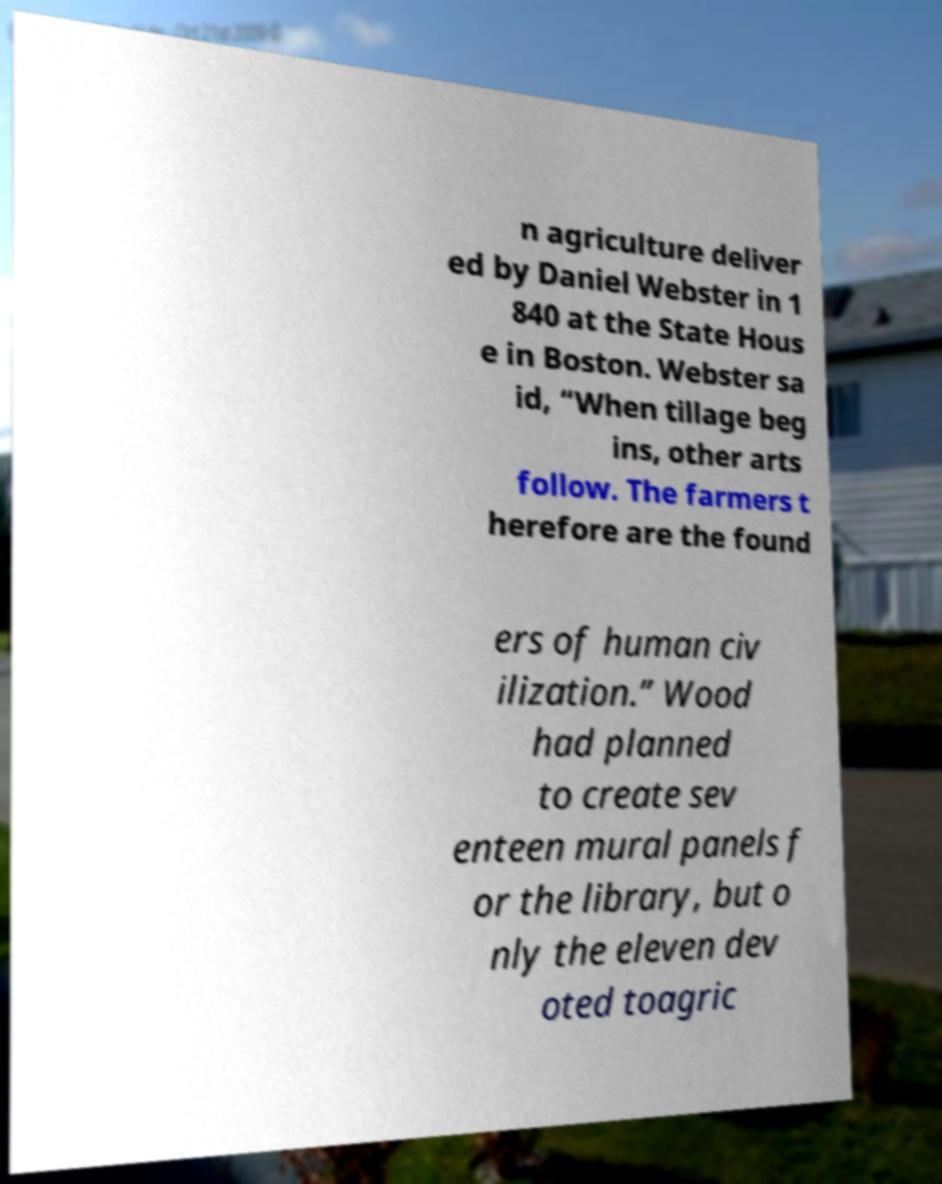Please read and relay the text visible in this image. What does it say? n agriculture deliver ed by Daniel Webster in 1 840 at the State Hous e in Boston. Webster sa id, “When tillage beg ins, other arts follow. The farmers t herefore are the found ers of human civ ilization.” Wood had planned to create sev enteen mural panels f or the library, but o nly the eleven dev oted toagric 